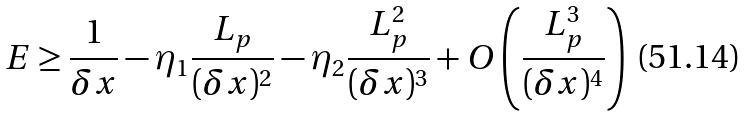Convert formula to latex. <formula><loc_0><loc_0><loc_500><loc_500>E \geq \frac { 1 } { \delta x } - \eta _ { 1 } \frac { L _ { p } } { ( \delta x ) ^ { 2 } } - \eta _ { 2 } \frac { L _ { p } ^ { 2 } } { ( \delta x ) ^ { 3 } } + O \left ( \frac { L _ { p } ^ { 3 } } { ( \delta x ) ^ { 4 } } \right )</formula> 